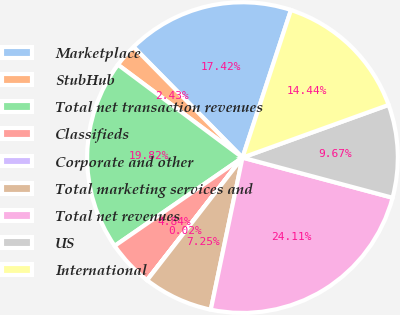Convert chart. <chart><loc_0><loc_0><loc_500><loc_500><pie_chart><fcel>Marketplace<fcel>StubHub<fcel>Total net transaction revenues<fcel>Classifieds<fcel>Corporate and other<fcel>Total marketing services and<fcel>Total net revenues<fcel>US<fcel>International<nl><fcel>17.42%<fcel>2.43%<fcel>19.82%<fcel>4.84%<fcel>0.02%<fcel>7.25%<fcel>24.11%<fcel>9.67%<fcel>14.44%<nl></chart> 